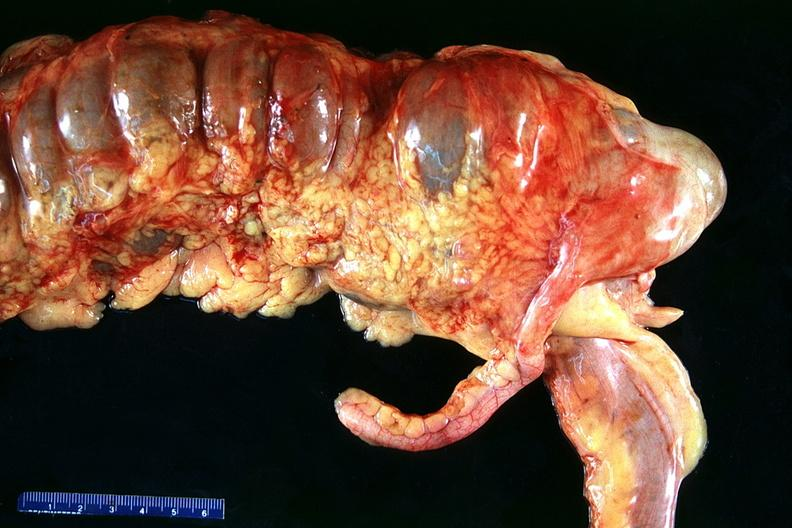what is present?
Answer the question using a single word or phrase. Gastrointestinal 